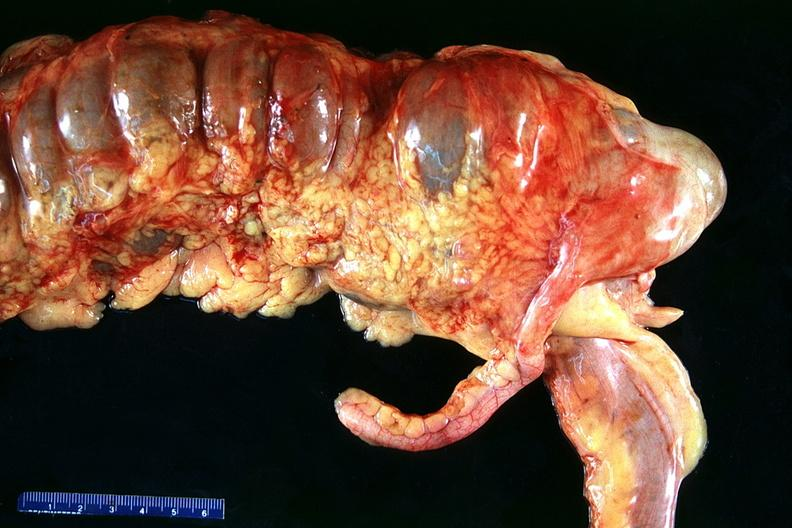what is present?
Answer the question using a single word or phrase. Gastrointestinal 